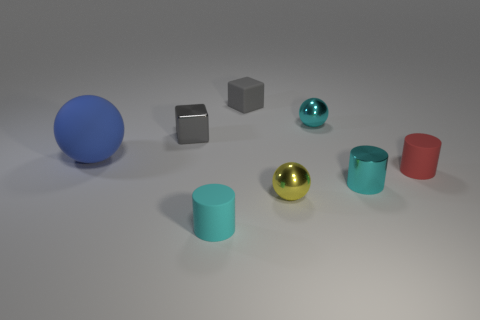Subtract all tiny red cylinders. How many cylinders are left? 2 Add 1 green rubber cubes. How many objects exist? 9 Subtract all cyan cylinders. How many cylinders are left? 1 Subtract 2 blocks. How many blocks are left? 0 Subtract all cylinders. How many objects are left? 5 Subtract all red cylinders. How many cyan spheres are left? 1 Add 2 rubber blocks. How many rubber blocks exist? 3 Subtract 0 red balls. How many objects are left? 8 Subtract all gray spheres. Subtract all blue blocks. How many spheres are left? 3 Subtract all cyan metal balls. Subtract all gray metal cylinders. How many objects are left? 7 